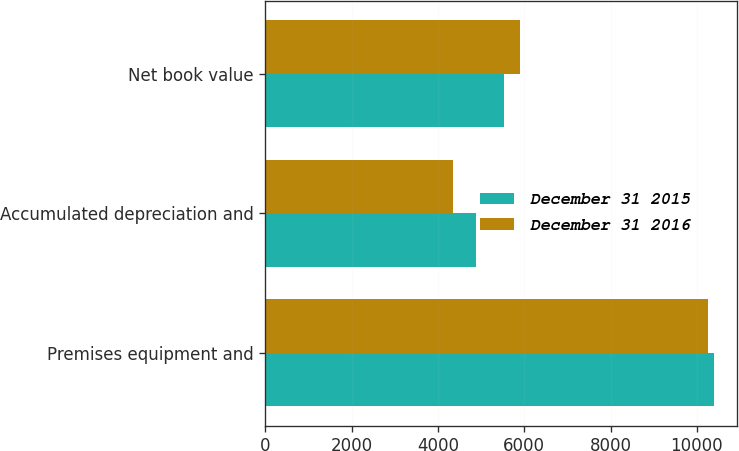<chart> <loc_0><loc_0><loc_500><loc_500><stacked_bar_chart><ecel><fcel>Premises equipment and<fcel>Accumulated depreciation and<fcel>Net book value<nl><fcel>December 31 2015<fcel>10410<fcel>4888<fcel>5522<nl><fcel>December 31 2016<fcel>10257<fcel>4349<fcel>5908<nl></chart> 